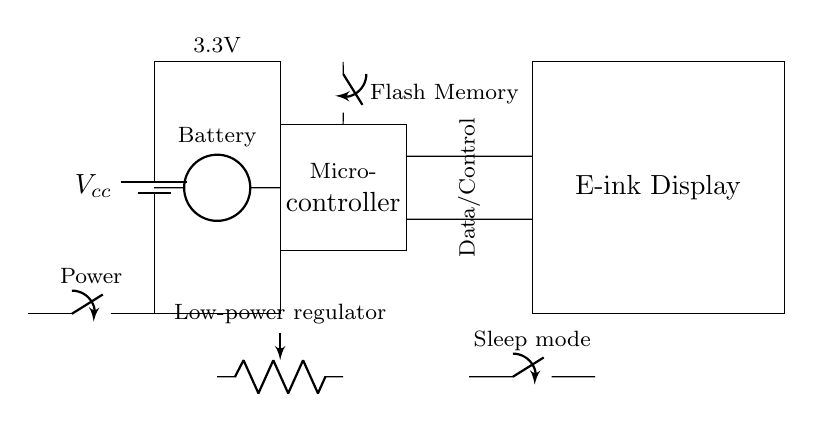What is the purpose of the power switch in this circuit? The power switch is used to control the flow of electricity from the battery to the rest of the circuit, allowing users to turn the device on or off easily.
Answer: Control flow What is the voltage of the power supply? The voltage of the power supply is indicated as 3.3V, which supplies power to the components in the circuit.
Answer: 3.3V How many components are connected to the microcontroller? There are three components connected to the microcontroller: the E-ink display, the flash memory, and the low-power regulator which is indirectly connected.
Answer: Three What type of memory is used in the circuit? The circuit uses flash memory as indicated by the labeled component next to the microcontroller.
Answer: Flash memory Why is a low-power regulator used in this circuit? A low-power regulator is used to ensure that the components receive a stable and reduced voltage, improving efficiency and prolonging battery life, especially important for portable devices.
Answer: Efficiency What feature does the sleep mode component provide? The sleep mode component allows the device to conserve power when not in active use, effectively reducing power consumption and extending battery life, which is crucial for low-power applications.
Answer: Power conservation What is the role of the battery in this circuit? The battery provides the necessary power to run the circuit, acting as the main source while supplying 3.3V to the system through the power management components.
Answer: Main power source 